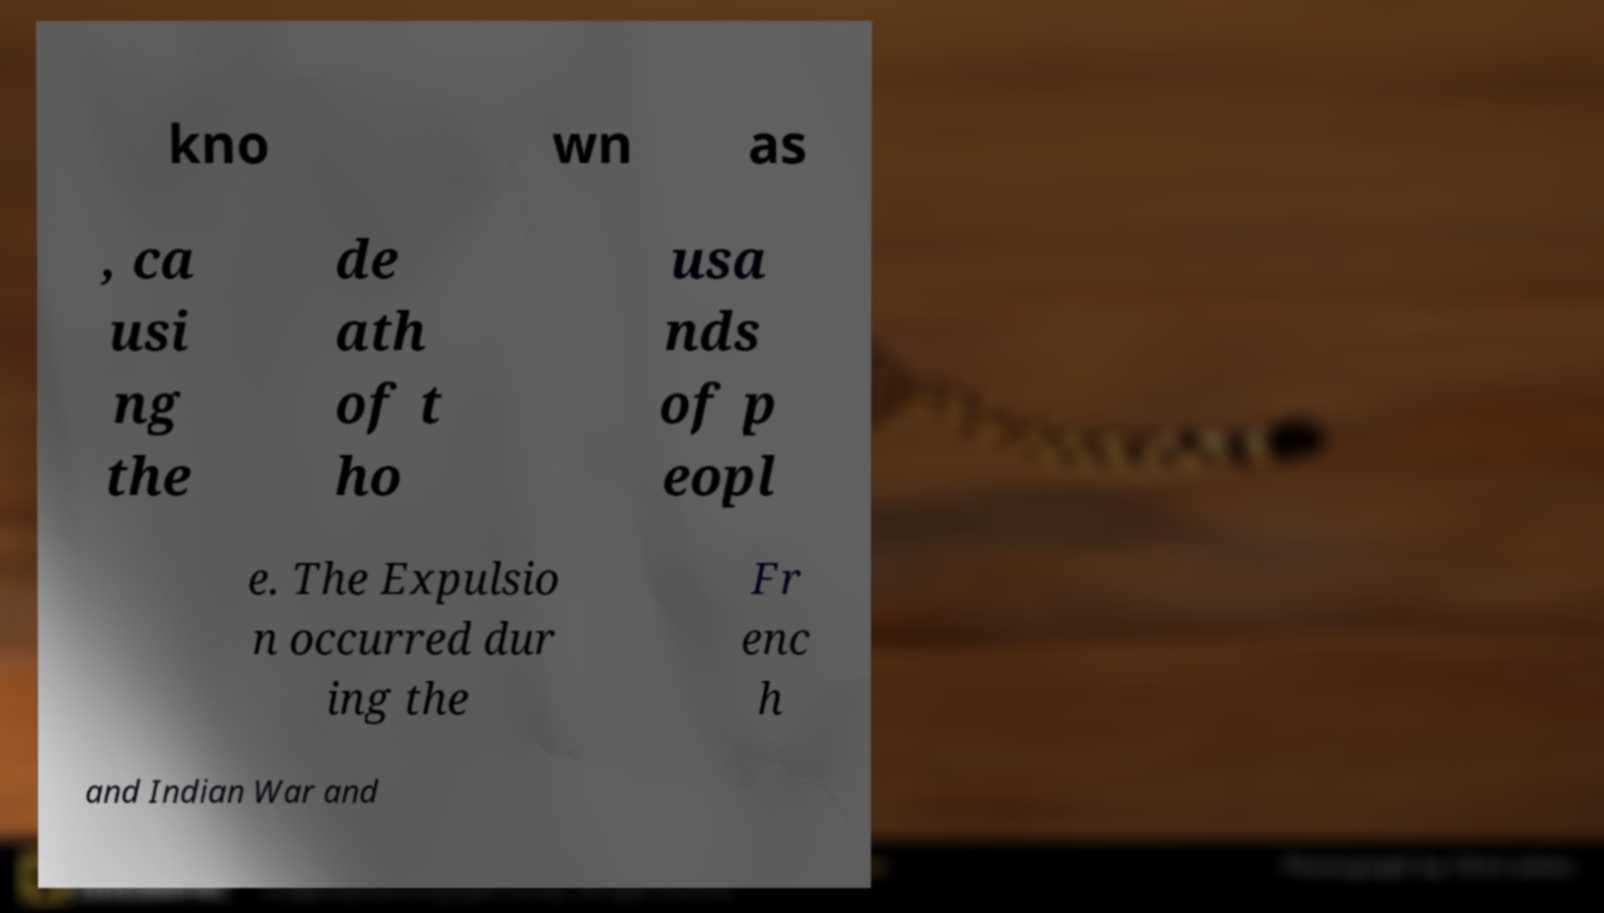Please read and relay the text visible in this image. What does it say? kno wn as , ca usi ng the de ath of t ho usa nds of p eopl e. The Expulsio n occurred dur ing the Fr enc h and Indian War and 